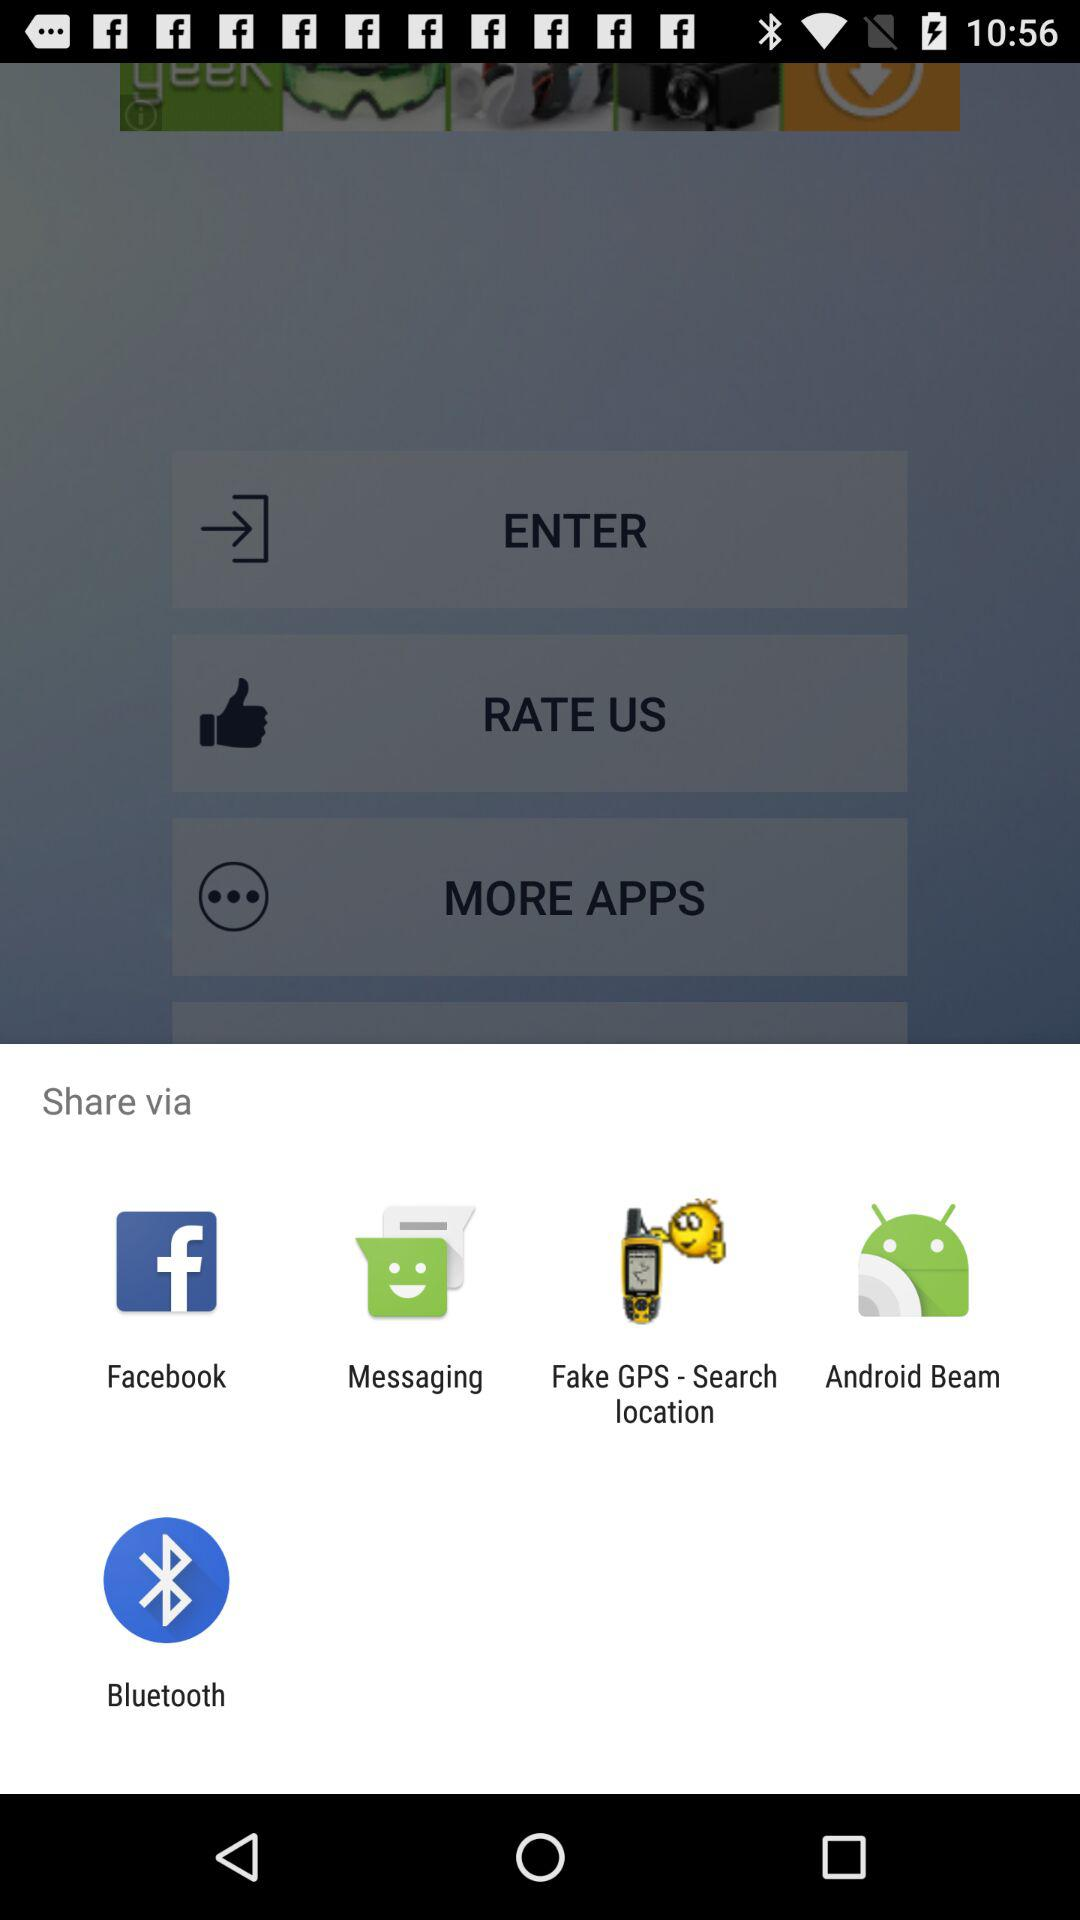How many items are in the share menu?
Answer the question using a single word or phrase. 5 